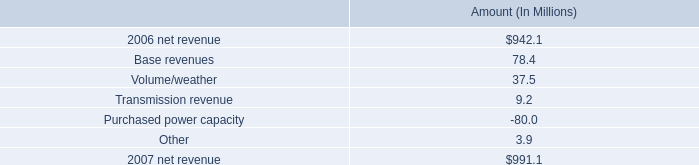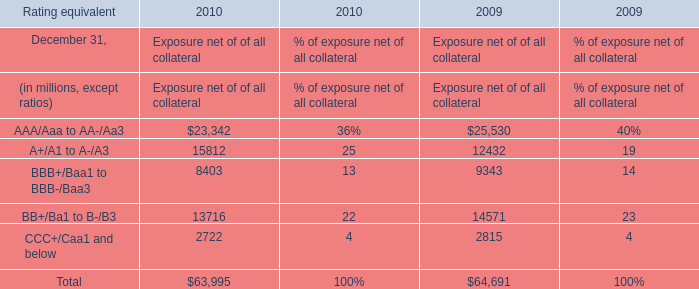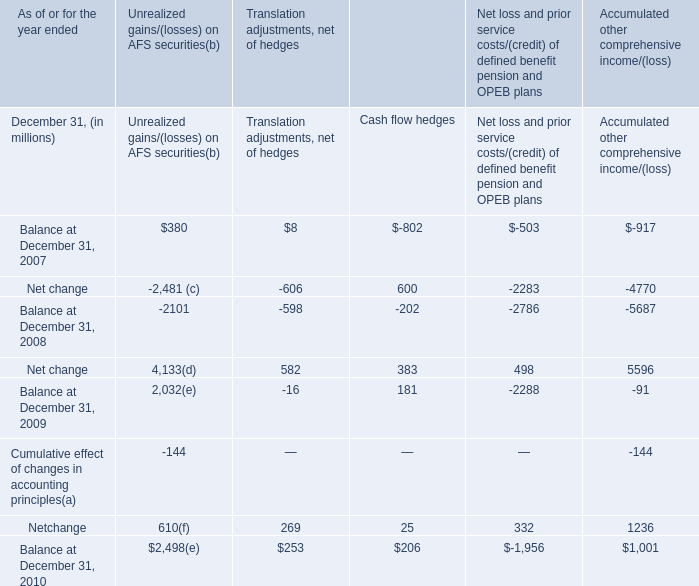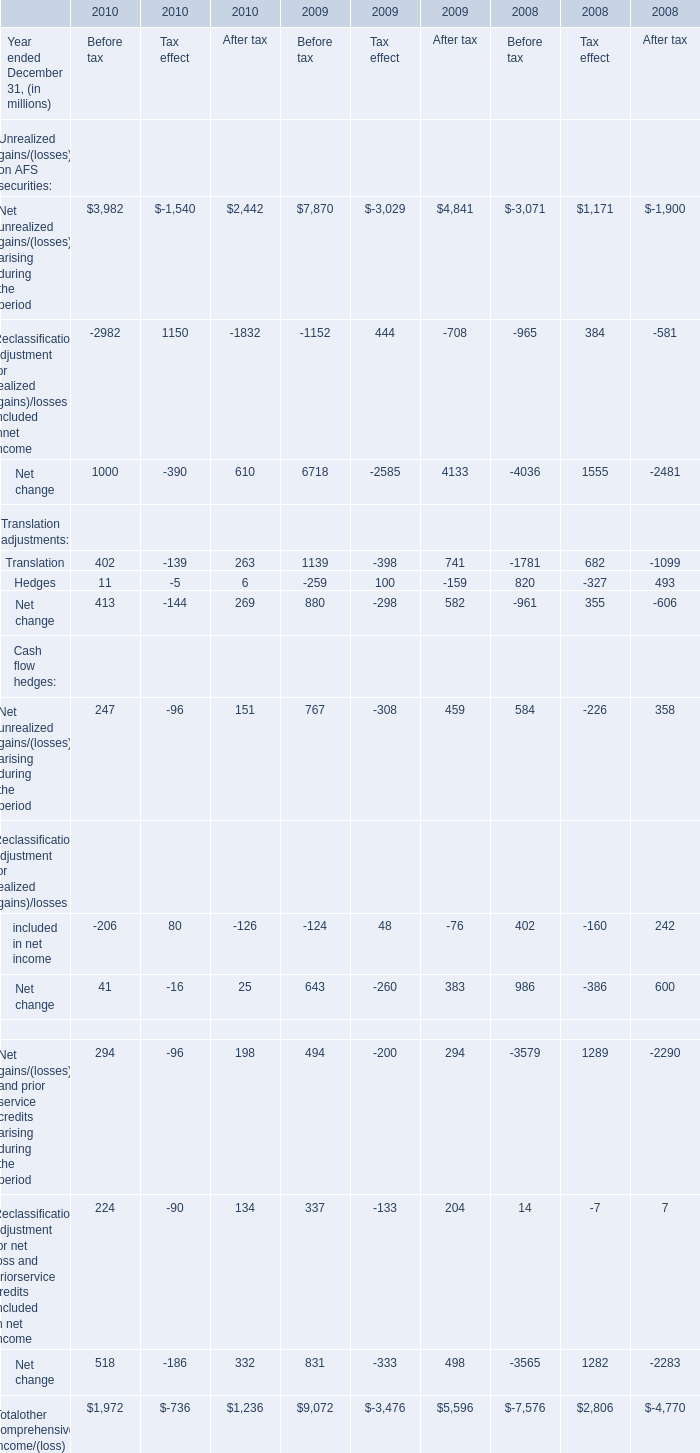When does Accumulated other comprehensive income/(loss) reach the largest value? 
Answer: 2010. 